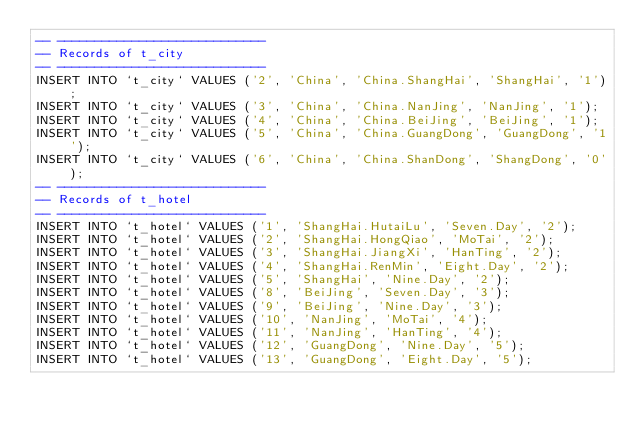Convert code to text. <code><loc_0><loc_0><loc_500><loc_500><_SQL_>-- ----------------------------
-- Records of t_city
-- ----------------------------
INSERT INTO `t_city` VALUES ('2', 'China', 'China.ShangHai', 'ShangHai', '1');
INSERT INTO `t_city` VALUES ('3', 'China', 'China.NanJing', 'NanJing', '1');
INSERT INTO `t_city` VALUES ('4', 'China', 'China.BeiJing', 'BeiJing', '1');
INSERT INTO `t_city` VALUES ('5', 'China', 'China.GuangDong', 'GuangDong', '1');
INSERT INTO `t_city` VALUES ('6', 'China', 'China.ShanDong', 'ShangDong', '0');
-- ----------------------------
-- Records of t_hotel
-- ----------------------------
INSERT INTO `t_hotel` VALUES ('1', 'ShangHai.HutaiLu', 'Seven.Day', '2');
INSERT INTO `t_hotel` VALUES ('2', 'ShangHai.HongQiao', 'MoTai', '2');
INSERT INTO `t_hotel` VALUES ('3', 'ShangHai.JiangXi', 'HanTing', '2');
INSERT INTO `t_hotel` VALUES ('4', 'ShangHai.RenMin', 'Eight.Day', '2');
INSERT INTO `t_hotel` VALUES ('5', 'ShangHai', 'Nine.Day', '2');
INSERT INTO `t_hotel` VALUES ('8', 'BeiJing', 'Seven.Day', '3');
INSERT INTO `t_hotel` VALUES ('9', 'BeiJing', 'Nine.Day', '3');
INSERT INTO `t_hotel` VALUES ('10', 'NanJing', 'MoTai', '4');
INSERT INTO `t_hotel` VALUES ('11', 'NanJing', 'HanTing', '4');
INSERT INTO `t_hotel` VALUES ('12', 'GuangDong', 'Nine.Day', '5');
INSERT INTO `t_hotel` VALUES ('13', 'GuangDong', 'Eight.Day', '5');
</code> 